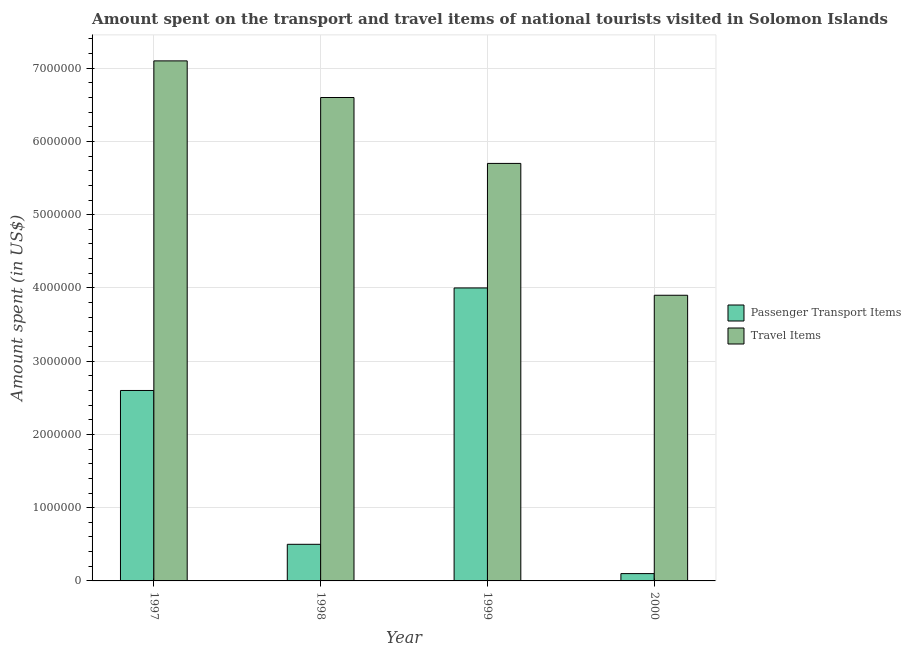How many different coloured bars are there?
Offer a terse response. 2. Are the number of bars on each tick of the X-axis equal?
Your answer should be compact. Yes. How many bars are there on the 4th tick from the left?
Make the answer very short. 2. How many bars are there on the 1st tick from the right?
Provide a short and direct response. 2. What is the label of the 1st group of bars from the left?
Ensure brevity in your answer.  1997. In how many cases, is the number of bars for a given year not equal to the number of legend labels?
Provide a succinct answer. 0. What is the amount spent on passenger transport items in 2000?
Your response must be concise. 1.00e+05. Across all years, what is the maximum amount spent in travel items?
Give a very brief answer. 7.10e+06. Across all years, what is the minimum amount spent on passenger transport items?
Make the answer very short. 1.00e+05. What is the total amount spent in travel items in the graph?
Offer a very short reply. 2.33e+07. What is the difference between the amount spent on passenger transport items in 1997 and that in 2000?
Your answer should be very brief. 2.50e+06. What is the difference between the amount spent on passenger transport items in 2000 and the amount spent in travel items in 1999?
Make the answer very short. -3.90e+06. What is the average amount spent on passenger transport items per year?
Offer a very short reply. 1.80e+06. In the year 1998, what is the difference between the amount spent on passenger transport items and amount spent in travel items?
Your answer should be very brief. 0. In how many years, is the amount spent on passenger transport items greater than 3000000 US$?
Offer a very short reply. 1. What is the ratio of the amount spent on passenger transport items in 1998 to that in 1999?
Make the answer very short. 0.12. Is the difference between the amount spent on passenger transport items in 1998 and 1999 greater than the difference between the amount spent in travel items in 1998 and 1999?
Offer a terse response. No. What is the difference between the highest and the lowest amount spent on passenger transport items?
Offer a terse response. 3.90e+06. What does the 1st bar from the left in 1999 represents?
Provide a short and direct response. Passenger Transport Items. What does the 2nd bar from the right in 1997 represents?
Offer a very short reply. Passenger Transport Items. Are all the bars in the graph horizontal?
Provide a succinct answer. No. How many years are there in the graph?
Make the answer very short. 4. Does the graph contain any zero values?
Offer a very short reply. No. Where does the legend appear in the graph?
Offer a terse response. Center right. How are the legend labels stacked?
Keep it short and to the point. Vertical. What is the title of the graph?
Keep it short and to the point. Amount spent on the transport and travel items of national tourists visited in Solomon Islands. Does "Private funds" appear as one of the legend labels in the graph?
Offer a very short reply. No. What is the label or title of the X-axis?
Give a very brief answer. Year. What is the label or title of the Y-axis?
Your answer should be very brief. Amount spent (in US$). What is the Amount spent (in US$) in Passenger Transport Items in 1997?
Provide a succinct answer. 2.60e+06. What is the Amount spent (in US$) of Travel Items in 1997?
Keep it short and to the point. 7.10e+06. What is the Amount spent (in US$) of Travel Items in 1998?
Ensure brevity in your answer.  6.60e+06. What is the Amount spent (in US$) in Travel Items in 1999?
Your answer should be very brief. 5.70e+06. What is the Amount spent (in US$) in Travel Items in 2000?
Offer a very short reply. 3.90e+06. Across all years, what is the maximum Amount spent (in US$) of Travel Items?
Keep it short and to the point. 7.10e+06. Across all years, what is the minimum Amount spent (in US$) of Passenger Transport Items?
Your answer should be very brief. 1.00e+05. Across all years, what is the minimum Amount spent (in US$) in Travel Items?
Give a very brief answer. 3.90e+06. What is the total Amount spent (in US$) of Passenger Transport Items in the graph?
Your response must be concise. 7.20e+06. What is the total Amount spent (in US$) of Travel Items in the graph?
Your answer should be very brief. 2.33e+07. What is the difference between the Amount spent (in US$) in Passenger Transport Items in 1997 and that in 1998?
Ensure brevity in your answer.  2.10e+06. What is the difference between the Amount spent (in US$) of Passenger Transport Items in 1997 and that in 1999?
Give a very brief answer. -1.40e+06. What is the difference between the Amount spent (in US$) of Travel Items in 1997 and that in 1999?
Offer a terse response. 1.40e+06. What is the difference between the Amount spent (in US$) of Passenger Transport Items in 1997 and that in 2000?
Keep it short and to the point. 2.50e+06. What is the difference between the Amount spent (in US$) in Travel Items in 1997 and that in 2000?
Provide a short and direct response. 3.20e+06. What is the difference between the Amount spent (in US$) in Passenger Transport Items in 1998 and that in 1999?
Make the answer very short. -3.50e+06. What is the difference between the Amount spent (in US$) of Travel Items in 1998 and that in 1999?
Your response must be concise. 9.00e+05. What is the difference between the Amount spent (in US$) in Travel Items in 1998 and that in 2000?
Keep it short and to the point. 2.70e+06. What is the difference between the Amount spent (in US$) in Passenger Transport Items in 1999 and that in 2000?
Provide a succinct answer. 3.90e+06. What is the difference between the Amount spent (in US$) in Travel Items in 1999 and that in 2000?
Make the answer very short. 1.80e+06. What is the difference between the Amount spent (in US$) of Passenger Transport Items in 1997 and the Amount spent (in US$) of Travel Items in 1998?
Give a very brief answer. -4.00e+06. What is the difference between the Amount spent (in US$) of Passenger Transport Items in 1997 and the Amount spent (in US$) of Travel Items in 1999?
Your response must be concise. -3.10e+06. What is the difference between the Amount spent (in US$) in Passenger Transport Items in 1997 and the Amount spent (in US$) in Travel Items in 2000?
Your response must be concise. -1.30e+06. What is the difference between the Amount spent (in US$) in Passenger Transport Items in 1998 and the Amount spent (in US$) in Travel Items in 1999?
Offer a terse response. -5.20e+06. What is the difference between the Amount spent (in US$) of Passenger Transport Items in 1998 and the Amount spent (in US$) of Travel Items in 2000?
Your answer should be very brief. -3.40e+06. What is the difference between the Amount spent (in US$) of Passenger Transport Items in 1999 and the Amount spent (in US$) of Travel Items in 2000?
Offer a very short reply. 1.00e+05. What is the average Amount spent (in US$) in Passenger Transport Items per year?
Provide a succinct answer. 1.80e+06. What is the average Amount spent (in US$) of Travel Items per year?
Your response must be concise. 5.82e+06. In the year 1997, what is the difference between the Amount spent (in US$) in Passenger Transport Items and Amount spent (in US$) in Travel Items?
Your answer should be very brief. -4.50e+06. In the year 1998, what is the difference between the Amount spent (in US$) in Passenger Transport Items and Amount spent (in US$) in Travel Items?
Ensure brevity in your answer.  -6.10e+06. In the year 1999, what is the difference between the Amount spent (in US$) in Passenger Transport Items and Amount spent (in US$) in Travel Items?
Offer a terse response. -1.70e+06. In the year 2000, what is the difference between the Amount spent (in US$) of Passenger Transport Items and Amount spent (in US$) of Travel Items?
Your response must be concise. -3.80e+06. What is the ratio of the Amount spent (in US$) in Travel Items in 1997 to that in 1998?
Make the answer very short. 1.08. What is the ratio of the Amount spent (in US$) of Passenger Transport Items in 1997 to that in 1999?
Your answer should be compact. 0.65. What is the ratio of the Amount spent (in US$) in Travel Items in 1997 to that in 1999?
Ensure brevity in your answer.  1.25. What is the ratio of the Amount spent (in US$) of Passenger Transport Items in 1997 to that in 2000?
Provide a short and direct response. 26. What is the ratio of the Amount spent (in US$) in Travel Items in 1997 to that in 2000?
Give a very brief answer. 1.82. What is the ratio of the Amount spent (in US$) of Travel Items in 1998 to that in 1999?
Give a very brief answer. 1.16. What is the ratio of the Amount spent (in US$) of Travel Items in 1998 to that in 2000?
Your response must be concise. 1.69. What is the ratio of the Amount spent (in US$) in Travel Items in 1999 to that in 2000?
Provide a succinct answer. 1.46. What is the difference between the highest and the second highest Amount spent (in US$) in Passenger Transport Items?
Provide a short and direct response. 1.40e+06. What is the difference between the highest and the second highest Amount spent (in US$) in Travel Items?
Provide a short and direct response. 5.00e+05. What is the difference between the highest and the lowest Amount spent (in US$) of Passenger Transport Items?
Make the answer very short. 3.90e+06. What is the difference between the highest and the lowest Amount spent (in US$) in Travel Items?
Make the answer very short. 3.20e+06. 